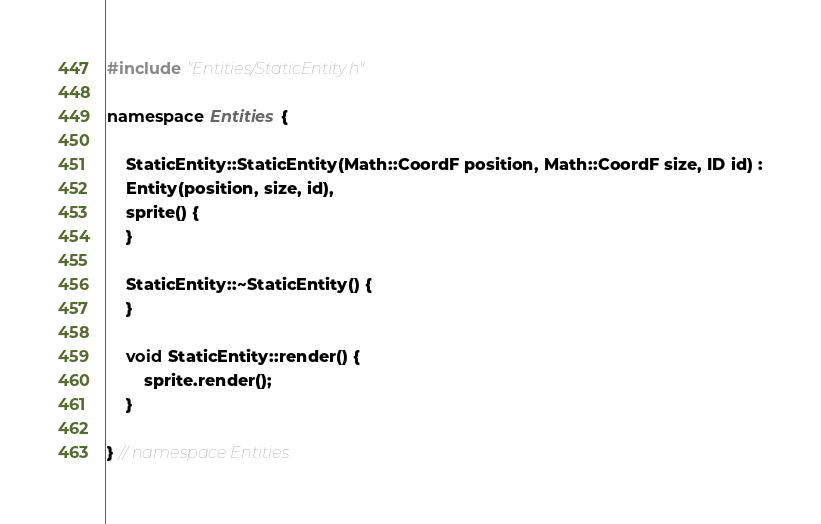Convert code to text. <code><loc_0><loc_0><loc_500><loc_500><_C++_>#include "Entities/StaticEntity.h"

namespace Entities {

    StaticEntity::StaticEntity(Math::CoordF position, Math::CoordF size, ID id) :
    Entity(position, size, id),
    sprite() {
    }

    StaticEntity::~StaticEntity() {
    }

    void StaticEntity::render() {
        sprite.render();
    }

} // namespace Entities
</code> 